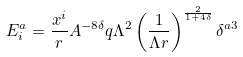<formula> <loc_0><loc_0><loc_500><loc_500>E ^ { a } _ { i } = \frac { x ^ { i } } { r } A ^ { - 8 \delta } q \Lambda ^ { 2 } \left ( \frac { 1 } { \Lambda r } \right ) ^ { \frac { 2 } { 1 + 4 \delta } } \delta ^ { a 3 }</formula> 